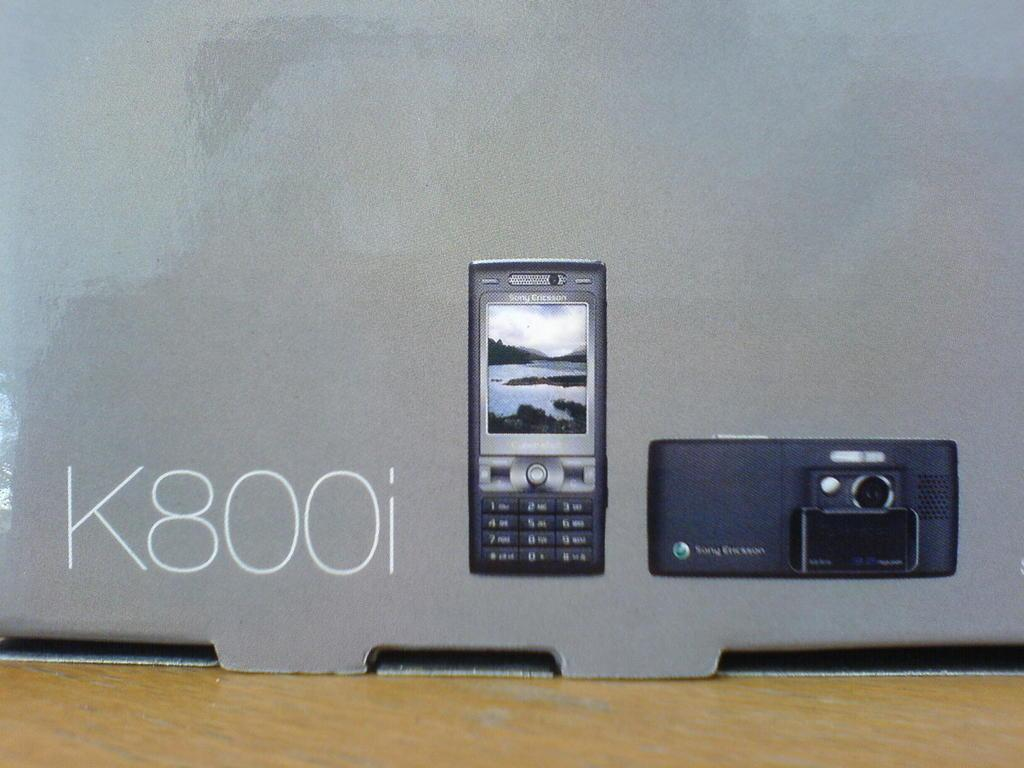<image>
Write a terse but informative summary of the picture. the letters K800i that are next to the phone 